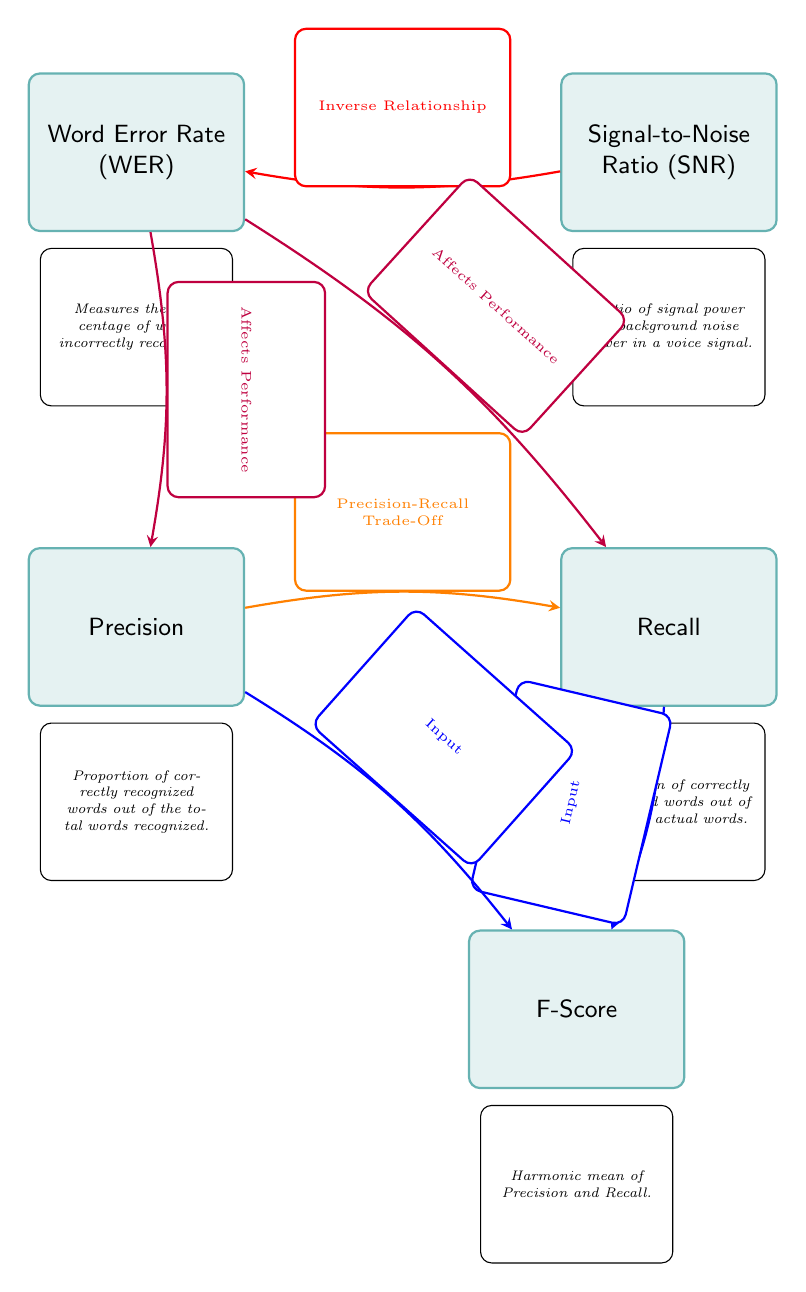What is the definition of Word Error Rate? The Word Error Rate (WER) is defined in the diagram as a measure of the percentage of words incorrectly recognized.
Answer: Percentage of words incorrectly recognized What does the Signal-to-Noise Ratio measure? The Signal-to-Noise Ratio (SNR) measures the ratio of signal power to background noise power in a voice signal.
Answer: Ratio of signal power to background noise power How many performance metrics are listed in the diagram? There are five performance metrics listed: Word Error Rate, Signal-to-Noise Ratio, Precision, Recall, and F-Score.
Answer: Five Which performance metric is affected by both Precision and Recall? The F-Score is affected by both Precision and Recall as indicated by arrows connecting them to F-Score.
Answer: F-Score What type of relationship does SNR have with WER? The relationship between SNR and WER is described as an inverse relationship according to the diagram.
Answer: Inverse Relationship Which two metrics show a trade-off relationship in the diagram? The Precision and Recall metrics show a trade-off relationship, as indicated by the orange arrow between them.
Answer: Precision and Recall What is the harmonic mean of which two metrics? The F-Score is the harmonic mean of Precision and Recall, as indicated by the blue arrows leading into F-Score.
Answer: Precision and Recall How does WER affect Precision and Recall? WER affects both Precision and Recall in terms of performance, as shown by the purple arrows going from WER to both metrics.
Answer: Affects Performance 